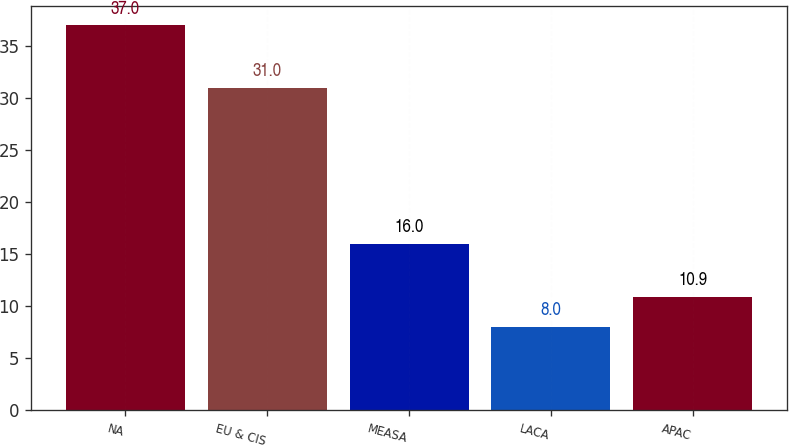Convert chart. <chart><loc_0><loc_0><loc_500><loc_500><bar_chart><fcel>NA<fcel>EU & CIS<fcel>MEASA<fcel>LACA<fcel>APAC<nl><fcel>37<fcel>31<fcel>16<fcel>8<fcel>10.9<nl></chart> 